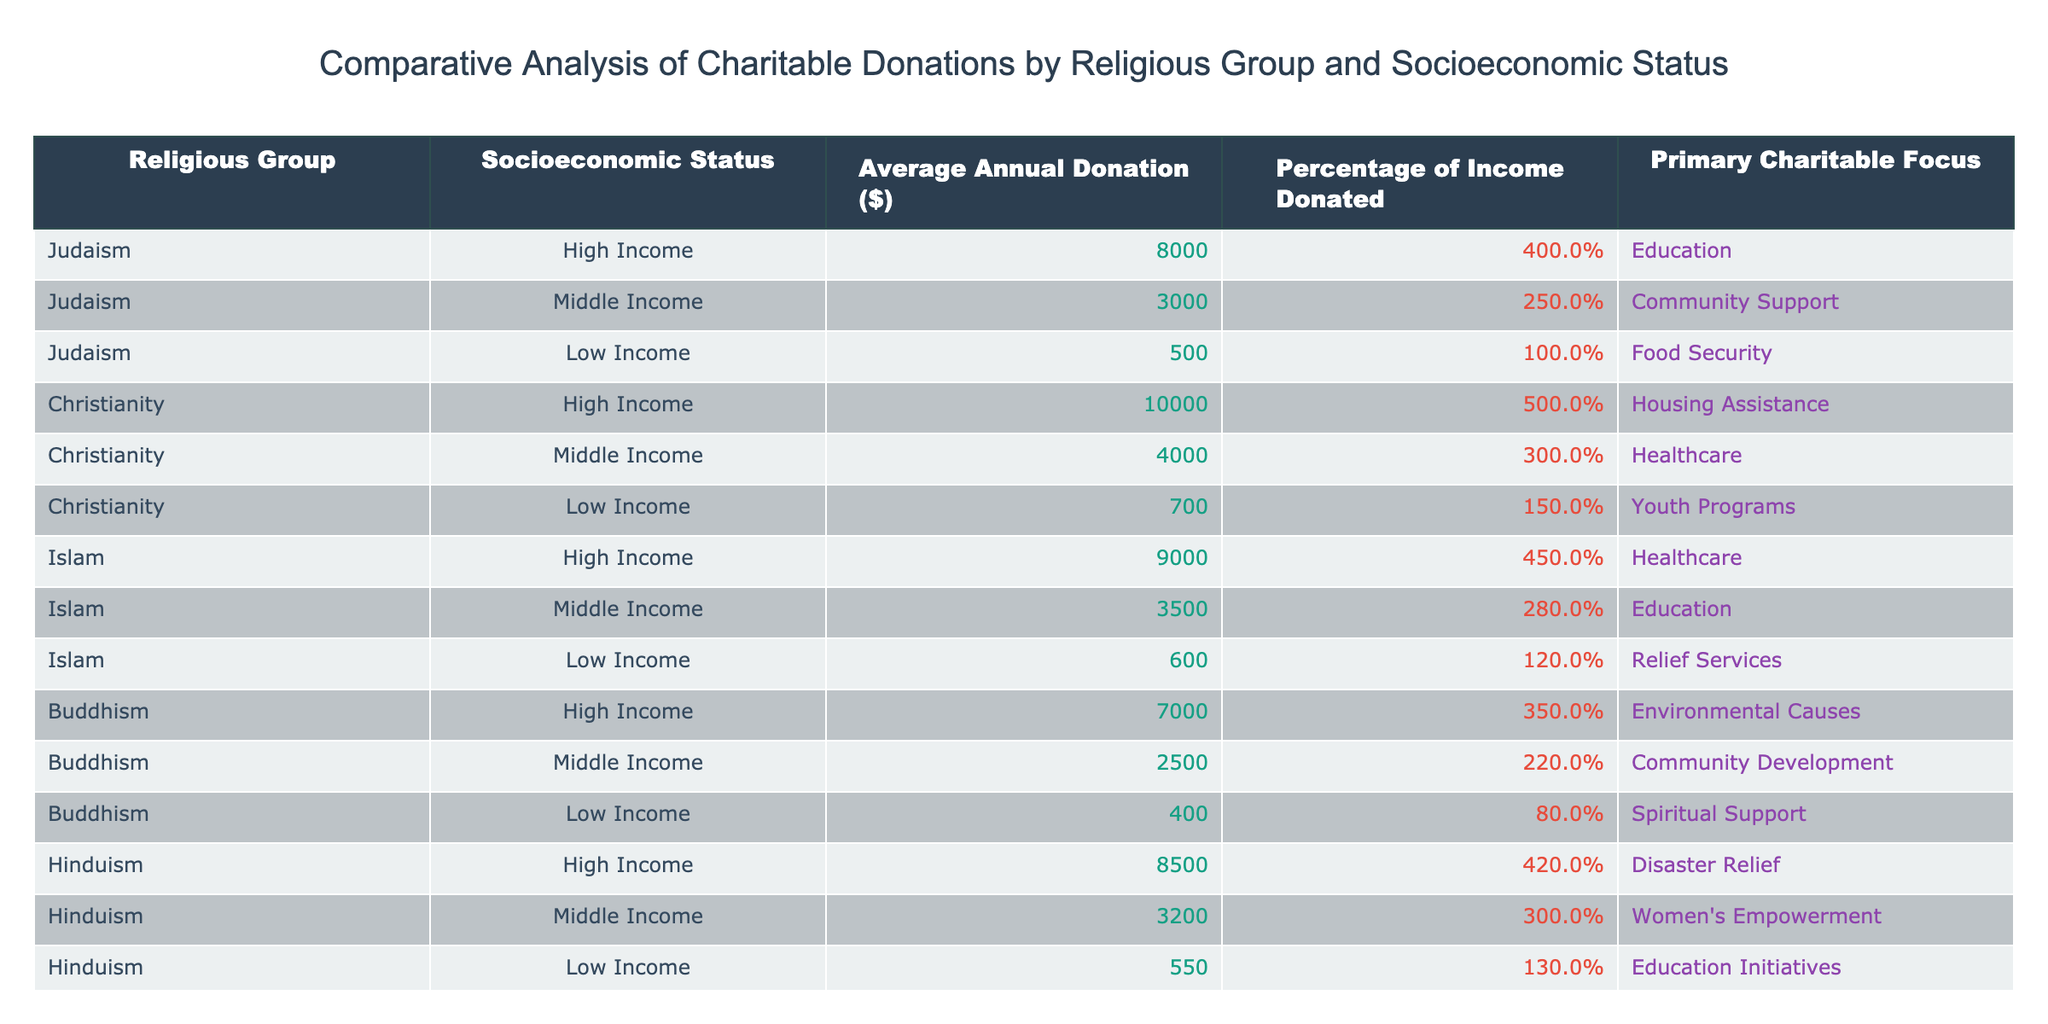What is the average annual donation for the Christian high-income group? The table lists the average annual donation for the Christian high-income group as $10,000.
Answer: 10000 What percentage of income do low-income Buddhists donate on average? The table shows that low-income Buddhists donate an average of 0.8% of their income.
Answer: 0.8% Which religious group has the highest average annual donation among middle-income donors? Comparing the average annual donations for middle-income groups: Judaism ($3,000), Christianity ($4,000), Islam ($3,500), Buddhism ($2,500), and Hinduism ($3,200). Christianity has the highest average at $4,000.
Answer: Christianity Is the primary charitable focus for high-income Muslims healthcare? The primary charitable focus for high-income Muslims is indeed healthcare as listed in the table.
Answer: Yes What is the combined average annual donation of low-income individuals across all religious groups? The average annual donations for low-income individuals are $500 (Judaism) + $700 (Christianity) + $600 (Islam) + $400 (Buddhism) + $550 (Hinduism) = $2,750. To find the average, we divide by 5 (the number of groups), giving us an average of $2,750/5 = $550.
Answer: 550 How does the average percentage of income donated by high-income Hindus compare to that of high-income Buddhists? High-income Hindus donate an average of 4.2% of their income while high-income Buddhists donate an average of 3.5%. Comparing the two, 4.2% is greater than 3.5%.
Answer: Higher What is the average annual donation difference between high-income Christians and high-income Hindus? The high-income Christian average is $10,000 and the high-income Hindu average is $8,500. The difference is $10,000 - $8,500 = $1,500.
Answer: 1500 Do middle-income individuals across all religious groups donate more than 3% of their income on average? Middle-income donations are $3,000 (Judaism - 2.5%), $4,000 (Christianity - 3.0%), $3,500 (Islam - 2.8%), $2,500 (Buddhism - 2.2%), and $3,200 (Hinduism - 3.0%). The average percentage is (2.5 + 3.0 + 2.8 + 2.2 + 3.0) / 5 = 2.7%. This is less than 3%.
Answer: No Which socioeconomic status category has the lowest average annual donation and what is the amount? Review the low-income average donations: Judaism ($500), Christianity ($700), Islam ($600), Buddhism ($400), and Hinduism ($550). The lowest amount is $400 from Buddhism.
Answer: $400 